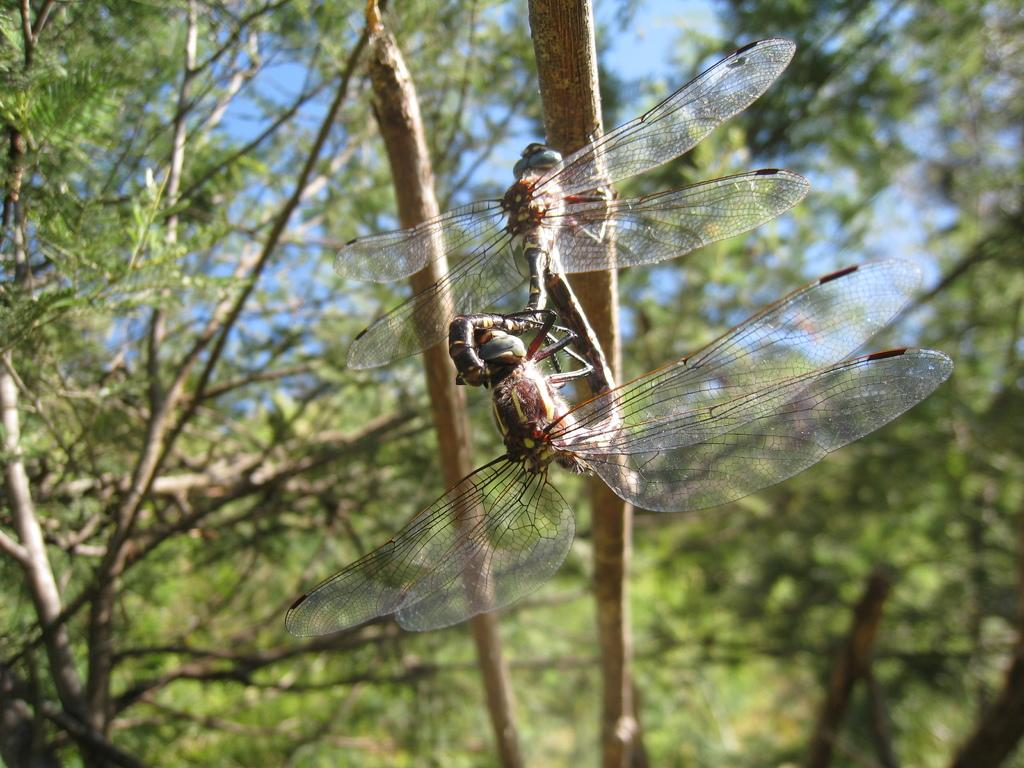What type of insect can be seen in the image? There is a dragonfly in the image. What is the dragonfly doing in the image? The dragonfly is flying in the image. What type of vegetation is present in the image? There is a tree in the image. How does the dragonfly escape from the quicksand in the image? There is no quicksand present in the image, as it only features a dragonfly flying near a tree. 